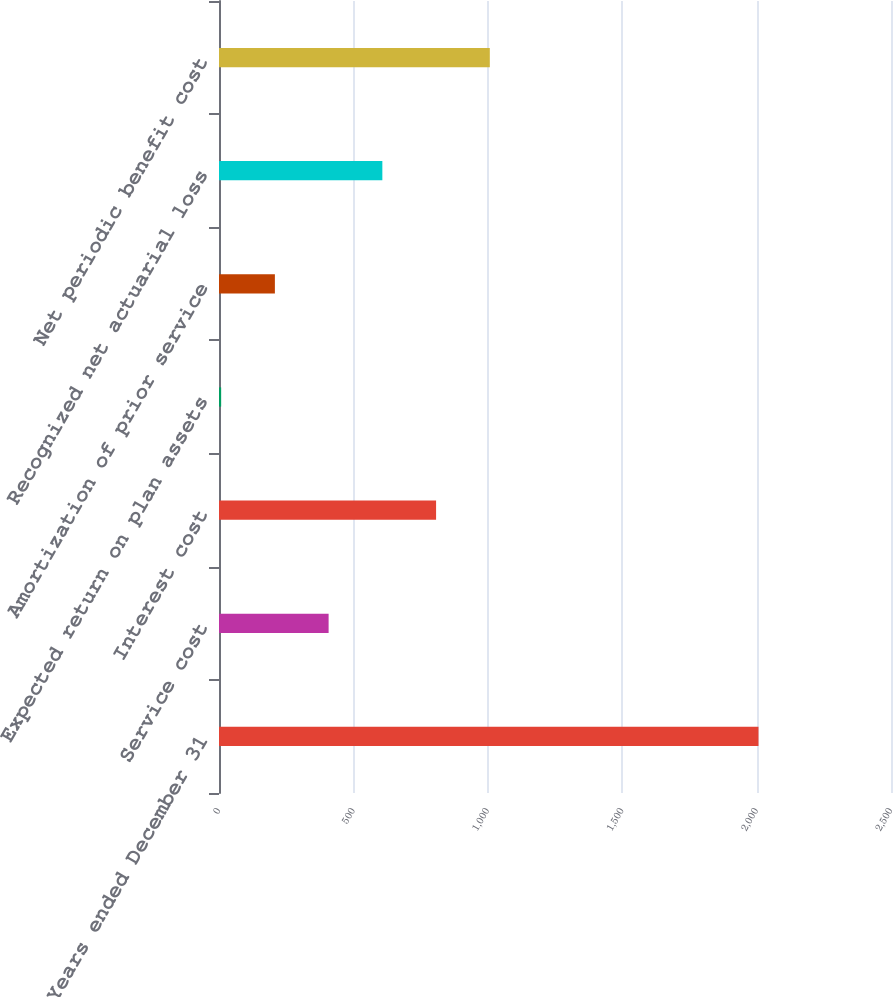Convert chart to OTSL. <chart><loc_0><loc_0><loc_500><loc_500><bar_chart><fcel>Years ended December 31<fcel>Service cost<fcel>Interest cost<fcel>Expected return on plan assets<fcel>Amortization of prior service<fcel>Recognized net actuarial loss<fcel>Net periodic benefit cost<nl><fcel>2007<fcel>407.8<fcel>807.6<fcel>8<fcel>207.9<fcel>607.7<fcel>1007.5<nl></chart> 